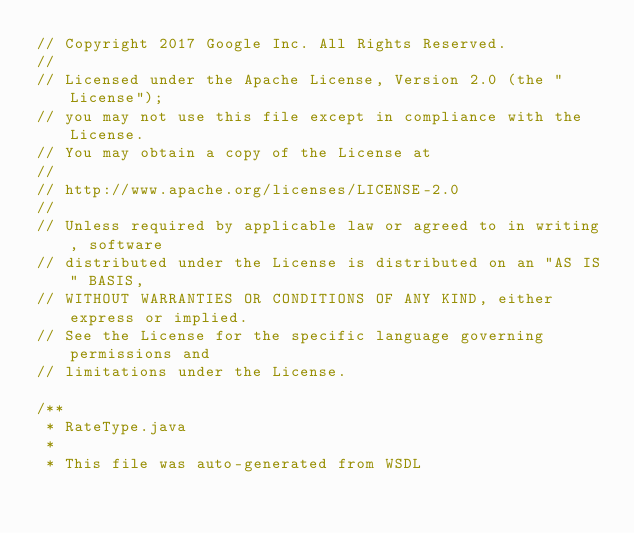<code> <loc_0><loc_0><loc_500><loc_500><_Java_>// Copyright 2017 Google Inc. All Rights Reserved.
//
// Licensed under the Apache License, Version 2.0 (the "License");
// you may not use this file except in compliance with the License.
// You may obtain a copy of the License at
//
// http://www.apache.org/licenses/LICENSE-2.0
//
// Unless required by applicable law or agreed to in writing, software
// distributed under the License is distributed on an "AS IS" BASIS,
// WITHOUT WARRANTIES OR CONDITIONS OF ANY KIND, either express or implied.
// See the License for the specific language governing permissions and
// limitations under the License.

/**
 * RateType.java
 *
 * This file was auto-generated from WSDL</code> 